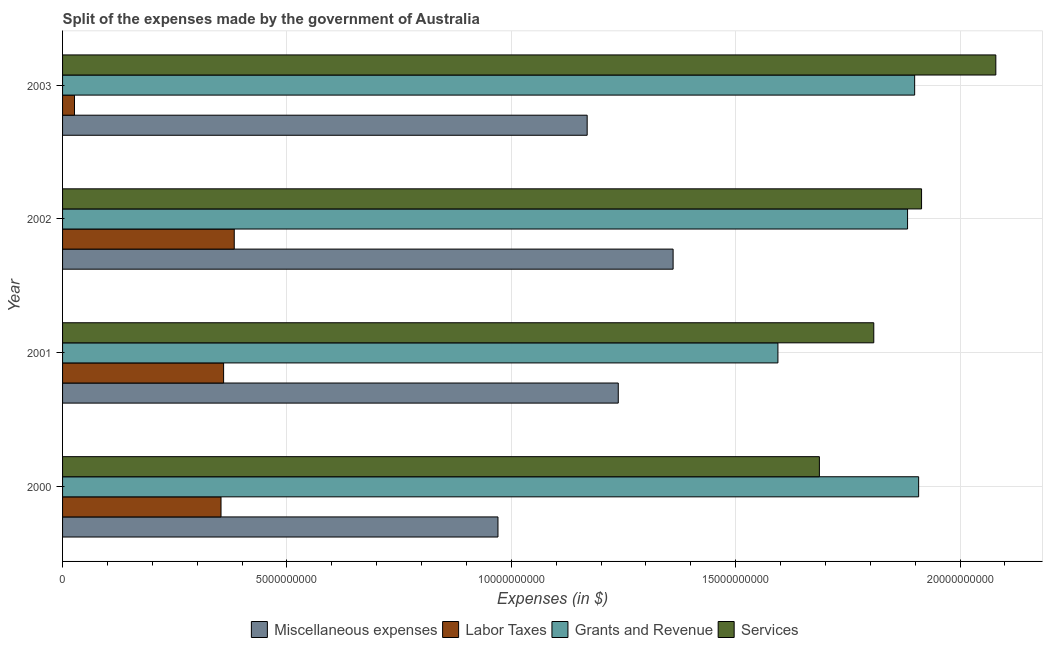How many different coloured bars are there?
Ensure brevity in your answer.  4. Are the number of bars on each tick of the Y-axis equal?
Your response must be concise. Yes. How many bars are there on the 1st tick from the bottom?
Provide a succinct answer. 4. What is the label of the 3rd group of bars from the top?
Provide a short and direct response. 2001. In how many cases, is the number of bars for a given year not equal to the number of legend labels?
Your answer should be compact. 0. What is the amount spent on services in 2000?
Offer a terse response. 1.69e+1. Across all years, what is the maximum amount spent on services?
Provide a short and direct response. 2.08e+1. Across all years, what is the minimum amount spent on services?
Your response must be concise. 1.69e+1. What is the total amount spent on miscellaneous expenses in the graph?
Make the answer very short. 4.74e+1. What is the difference between the amount spent on labor taxes in 2000 and that in 2001?
Offer a terse response. -5.80e+07. What is the difference between the amount spent on miscellaneous expenses in 2003 and the amount spent on labor taxes in 2002?
Ensure brevity in your answer.  7.86e+09. What is the average amount spent on grants and revenue per year?
Keep it short and to the point. 1.82e+1. In the year 2000, what is the difference between the amount spent on services and amount spent on labor taxes?
Offer a very short reply. 1.33e+1. In how many years, is the amount spent on labor taxes greater than 16000000000 $?
Your answer should be compact. 0. What is the ratio of the amount spent on services in 2001 to that in 2003?
Offer a very short reply. 0.87. What is the difference between the highest and the second highest amount spent on miscellaneous expenses?
Keep it short and to the point. 1.22e+09. What is the difference between the highest and the lowest amount spent on miscellaneous expenses?
Your answer should be very brief. 3.90e+09. In how many years, is the amount spent on miscellaneous expenses greater than the average amount spent on miscellaneous expenses taken over all years?
Provide a short and direct response. 2. What does the 1st bar from the top in 2001 represents?
Provide a succinct answer. Services. What does the 4th bar from the bottom in 2002 represents?
Offer a terse response. Services. Is it the case that in every year, the sum of the amount spent on miscellaneous expenses and amount spent on labor taxes is greater than the amount spent on grants and revenue?
Make the answer very short. No. How many bars are there?
Provide a short and direct response. 16. Are all the bars in the graph horizontal?
Your answer should be very brief. Yes. How many years are there in the graph?
Your response must be concise. 4. What is the difference between two consecutive major ticks on the X-axis?
Give a very brief answer. 5.00e+09. Are the values on the major ticks of X-axis written in scientific E-notation?
Provide a short and direct response. No. Where does the legend appear in the graph?
Offer a very short reply. Bottom center. How many legend labels are there?
Your answer should be compact. 4. How are the legend labels stacked?
Your response must be concise. Horizontal. What is the title of the graph?
Your answer should be very brief. Split of the expenses made by the government of Australia. What is the label or title of the X-axis?
Offer a terse response. Expenses (in $). What is the label or title of the Y-axis?
Keep it short and to the point. Year. What is the Expenses (in $) of Miscellaneous expenses in 2000?
Provide a short and direct response. 9.70e+09. What is the Expenses (in $) of Labor Taxes in 2000?
Provide a succinct answer. 3.53e+09. What is the Expenses (in $) of Grants and Revenue in 2000?
Make the answer very short. 1.91e+1. What is the Expenses (in $) in Services in 2000?
Your response must be concise. 1.69e+1. What is the Expenses (in $) in Miscellaneous expenses in 2001?
Provide a short and direct response. 1.24e+1. What is the Expenses (in $) in Labor Taxes in 2001?
Keep it short and to the point. 3.59e+09. What is the Expenses (in $) of Grants and Revenue in 2001?
Make the answer very short. 1.59e+1. What is the Expenses (in $) in Services in 2001?
Make the answer very short. 1.81e+1. What is the Expenses (in $) in Miscellaneous expenses in 2002?
Offer a very short reply. 1.36e+1. What is the Expenses (in $) in Labor Taxes in 2002?
Provide a short and direct response. 3.83e+09. What is the Expenses (in $) of Grants and Revenue in 2002?
Provide a succinct answer. 1.88e+1. What is the Expenses (in $) of Services in 2002?
Offer a terse response. 1.91e+1. What is the Expenses (in $) in Miscellaneous expenses in 2003?
Ensure brevity in your answer.  1.17e+1. What is the Expenses (in $) in Labor Taxes in 2003?
Ensure brevity in your answer.  2.66e+08. What is the Expenses (in $) in Grants and Revenue in 2003?
Provide a succinct answer. 1.90e+1. What is the Expenses (in $) of Services in 2003?
Offer a terse response. 2.08e+1. Across all years, what is the maximum Expenses (in $) in Miscellaneous expenses?
Offer a very short reply. 1.36e+1. Across all years, what is the maximum Expenses (in $) in Labor Taxes?
Make the answer very short. 3.83e+09. Across all years, what is the maximum Expenses (in $) of Grants and Revenue?
Offer a terse response. 1.91e+1. Across all years, what is the maximum Expenses (in $) of Services?
Offer a very short reply. 2.08e+1. Across all years, what is the minimum Expenses (in $) of Miscellaneous expenses?
Offer a terse response. 9.70e+09. Across all years, what is the minimum Expenses (in $) in Labor Taxes?
Your answer should be compact. 2.66e+08. Across all years, what is the minimum Expenses (in $) of Grants and Revenue?
Give a very brief answer. 1.59e+1. Across all years, what is the minimum Expenses (in $) of Services?
Your response must be concise. 1.69e+1. What is the total Expenses (in $) of Miscellaneous expenses in the graph?
Ensure brevity in your answer.  4.74e+1. What is the total Expenses (in $) in Labor Taxes in the graph?
Offer a terse response. 1.12e+1. What is the total Expenses (in $) in Grants and Revenue in the graph?
Provide a succinct answer. 7.28e+1. What is the total Expenses (in $) in Services in the graph?
Keep it short and to the point. 7.49e+1. What is the difference between the Expenses (in $) of Miscellaneous expenses in 2000 and that in 2001?
Give a very brief answer. -2.68e+09. What is the difference between the Expenses (in $) of Labor Taxes in 2000 and that in 2001?
Your answer should be compact. -5.80e+07. What is the difference between the Expenses (in $) in Grants and Revenue in 2000 and that in 2001?
Provide a succinct answer. 3.14e+09. What is the difference between the Expenses (in $) in Services in 2000 and that in 2001?
Provide a short and direct response. -1.21e+09. What is the difference between the Expenses (in $) of Miscellaneous expenses in 2000 and that in 2002?
Your response must be concise. -3.90e+09. What is the difference between the Expenses (in $) in Labor Taxes in 2000 and that in 2002?
Offer a very short reply. -2.95e+08. What is the difference between the Expenses (in $) of Grants and Revenue in 2000 and that in 2002?
Offer a very short reply. 2.47e+08. What is the difference between the Expenses (in $) of Services in 2000 and that in 2002?
Your response must be concise. -2.28e+09. What is the difference between the Expenses (in $) of Miscellaneous expenses in 2000 and that in 2003?
Keep it short and to the point. -1.99e+09. What is the difference between the Expenses (in $) in Labor Taxes in 2000 and that in 2003?
Give a very brief answer. 3.26e+09. What is the difference between the Expenses (in $) in Grants and Revenue in 2000 and that in 2003?
Your answer should be compact. 8.90e+07. What is the difference between the Expenses (in $) in Services in 2000 and that in 2003?
Give a very brief answer. -3.93e+09. What is the difference between the Expenses (in $) in Miscellaneous expenses in 2001 and that in 2002?
Your response must be concise. -1.22e+09. What is the difference between the Expenses (in $) in Labor Taxes in 2001 and that in 2002?
Offer a terse response. -2.37e+08. What is the difference between the Expenses (in $) in Grants and Revenue in 2001 and that in 2002?
Your answer should be very brief. -2.89e+09. What is the difference between the Expenses (in $) of Services in 2001 and that in 2002?
Your answer should be very brief. -1.06e+09. What is the difference between the Expenses (in $) of Miscellaneous expenses in 2001 and that in 2003?
Your answer should be compact. 6.93e+08. What is the difference between the Expenses (in $) of Labor Taxes in 2001 and that in 2003?
Offer a terse response. 3.32e+09. What is the difference between the Expenses (in $) of Grants and Revenue in 2001 and that in 2003?
Your answer should be compact. -3.05e+09. What is the difference between the Expenses (in $) in Services in 2001 and that in 2003?
Your answer should be very brief. -2.72e+09. What is the difference between the Expenses (in $) in Miscellaneous expenses in 2002 and that in 2003?
Your response must be concise. 1.92e+09. What is the difference between the Expenses (in $) in Labor Taxes in 2002 and that in 2003?
Provide a short and direct response. 3.56e+09. What is the difference between the Expenses (in $) in Grants and Revenue in 2002 and that in 2003?
Give a very brief answer. -1.58e+08. What is the difference between the Expenses (in $) in Services in 2002 and that in 2003?
Provide a short and direct response. -1.66e+09. What is the difference between the Expenses (in $) in Miscellaneous expenses in 2000 and the Expenses (in $) in Labor Taxes in 2001?
Keep it short and to the point. 6.11e+09. What is the difference between the Expenses (in $) of Miscellaneous expenses in 2000 and the Expenses (in $) of Grants and Revenue in 2001?
Ensure brevity in your answer.  -6.24e+09. What is the difference between the Expenses (in $) of Miscellaneous expenses in 2000 and the Expenses (in $) of Services in 2001?
Make the answer very short. -8.38e+09. What is the difference between the Expenses (in $) in Labor Taxes in 2000 and the Expenses (in $) in Grants and Revenue in 2001?
Ensure brevity in your answer.  -1.24e+1. What is the difference between the Expenses (in $) in Labor Taxes in 2000 and the Expenses (in $) in Services in 2001?
Provide a succinct answer. -1.45e+1. What is the difference between the Expenses (in $) in Miscellaneous expenses in 2000 and the Expenses (in $) in Labor Taxes in 2002?
Provide a short and direct response. 5.88e+09. What is the difference between the Expenses (in $) in Miscellaneous expenses in 2000 and the Expenses (in $) in Grants and Revenue in 2002?
Make the answer very short. -9.13e+09. What is the difference between the Expenses (in $) in Miscellaneous expenses in 2000 and the Expenses (in $) in Services in 2002?
Make the answer very short. -9.44e+09. What is the difference between the Expenses (in $) in Labor Taxes in 2000 and the Expenses (in $) in Grants and Revenue in 2002?
Provide a succinct answer. -1.53e+1. What is the difference between the Expenses (in $) in Labor Taxes in 2000 and the Expenses (in $) in Services in 2002?
Your answer should be compact. -1.56e+1. What is the difference between the Expenses (in $) in Grants and Revenue in 2000 and the Expenses (in $) in Services in 2002?
Provide a succinct answer. -6.50e+07. What is the difference between the Expenses (in $) of Miscellaneous expenses in 2000 and the Expenses (in $) of Labor Taxes in 2003?
Your answer should be compact. 9.44e+09. What is the difference between the Expenses (in $) of Miscellaneous expenses in 2000 and the Expenses (in $) of Grants and Revenue in 2003?
Ensure brevity in your answer.  -9.29e+09. What is the difference between the Expenses (in $) of Miscellaneous expenses in 2000 and the Expenses (in $) of Services in 2003?
Offer a very short reply. -1.11e+1. What is the difference between the Expenses (in $) of Labor Taxes in 2000 and the Expenses (in $) of Grants and Revenue in 2003?
Ensure brevity in your answer.  -1.55e+1. What is the difference between the Expenses (in $) of Labor Taxes in 2000 and the Expenses (in $) of Services in 2003?
Make the answer very short. -1.73e+1. What is the difference between the Expenses (in $) in Grants and Revenue in 2000 and the Expenses (in $) in Services in 2003?
Provide a short and direct response. -1.72e+09. What is the difference between the Expenses (in $) of Miscellaneous expenses in 2001 and the Expenses (in $) of Labor Taxes in 2002?
Offer a terse response. 8.56e+09. What is the difference between the Expenses (in $) in Miscellaneous expenses in 2001 and the Expenses (in $) in Grants and Revenue in 2002?
Provide a succinct answer. -6.45e+09. What is the difference between the Expenses (in $) in Miscellaneous expenses in 2001 and the Expenses (in $) in Services in 2002?
Give a very brief answer. -6.76e+09. What is the difference between the Expenses (in $) in Labor Taxes in 2001 and the Expenses (in $) in Grants and Revenue in 2002?
Offer a terse response. -1.52e+1. What is the difference between the Expenses (in $) of Labor Taxes in 2001 and the Expenses (in $) of Services in 2002?
Offer a terse response. -1.56e+1. What is the difference between the Expenses (in $) in Grants and Revenue in 2001 and the Expenses (in $) in Services in 2002?
Your answer should be very brief. -3.20e+09. What is the difference between the Expenses (in $) of Miscellaneous expenses in 2001 and the Expenses (in $) of Labor Taxes in 2003?
Provide a succinct answer. 1.21e+1. What is the difference between the Expenses (in $) in Miscellaneous expenses in 2001 and the Expenses (in $) in Grants and Revenue in 2003?
Provide a succinct answer. -6.60e+09. What is the difference between the Expenses (in $) in Miscellaneous expenses in 2001 and the Expenses (in $) in Services in 2003?
Offer a very short reply. -8.41e+09. What is the difference between the Expenses (in $) of Labor Taxes in 2001 and the Expenses (in $) of Grants and Revenue in 2003?
Ensure brevity in your answer.  -1.54e+1. What is the difference between the Expenses (in $) of Labor Taxes in 2001 and the Expenses (in $) of Services in 2003?
Your answer should be compact. -1.72e+1. What is the difference between the Expenses (in $) of Grants and Revenue in 2001 and the Expenses (in $) of Services in 2003?
Offer a very short reply. -4.86e+09. What is the difference between the Expenses (in $) of Miscellaneous expenses in 2002 and the Expenses (in $) of Labor Taxes in 2003?
Your answer should be compact. 1.33e+1. What is the difference between the Expenses (in $) in Miscellaneous expenses in 2002 and the Expenses (in $) in Grants and Revenue in 2003?
Give a very brief answer. -5.38e+09. What is the difference between the Expenses (in $) in Miscellaneous expenses in 2002 and the Expenses (in $) in Services in 2003?
Your answer should be very brief. -7.19e+09. What is the difference between the Expenses (in $) in Labor Taxes in 2002 and the Expenses (in $) in Grants and Revenue in 2003?
Offer a very short reply. -1.52e+1. What is the difference between the Expenses (in $) in Labor Taxes in 2002 and the Expenses (in $) in Services in 2003?
Your response must be concise. -1.70e+1. What is the difference between the Expenses (in $) in Grants and Revenue in 2002 and the Expenses (in $) in Services in 2003?
Make the answer very short. -1.97e+09. What is the average Expenses (in $) of Miscellaneous expenses per year?
Your answer should be very brief. 1.18e+1. What is the average Expenses (in $) of Labor Taxes per year?
Offer a terse response. 2.80e+09. What is the average Expenses (in $) in Grants and Revenue per year?
Offer a very short reply. 1.82e+1. What is the average Expenses (in $) of Services per year?
Your answer should be very brief. 1.87e+1. In the year 2000, what is the difference between the Expenses (in $) in Miscellaneous expenses and Expenses (in $) in Labor Taxes?
Give a very brief answer. 6.17e+09. In the year 2000, what is the difference between the Expenses (in $) in Miscellaneous expenses and Expenses (in $) in Grants and Revenue?
Your answer should be compact. -9.38e+09. In the year 2000, what is the difference between the Expenses (in $) of Miscellaneous expenses and Expenses (in $) of Services?
Keep it short and to the point. -7.16e+09. In the year 2000, what is the difference between the Expenses (in $) in Labor Taxes and Expenses (in $) in Grants and Revenue?
Your answer should be very brief. -1.55e+1. In the year 2000, what is the difference between the Expenses (in $) in Labor Taxes and Expenses (in $) in Services?
Your response must be concise. -1.33e+1. In the year 2000, what is the difference between the Expenses (in $) in Grants and Revenue and Expenses (in $) in Services?
Your response must be concise. 2.21e+09. In the year 2001, what is the difference between the Expenses (in $) in Miscellaneous expenses and Expenses (in $) in Labor Taxes?
Your answer should be very brief. 8.80e+09. In the year 2001, what is the difference between the Expenses (in $) in Miscellaneous expenses and Expenses (in $) in Grants and Revenue?
Make the answer very short. -3.56e+09. In the year 2001, what is the difference between the Expenses (in $) of Miscellaneous expenses and Expenses (in $) of Services?
Give a very brief answer. -5.69e+09. In the year 2001, what is the difference between the Expenses (in $) of Labor Taxes and Expenses (in $) of Grants and Revenue?
Your answer should be very brief. -1.24e+1. In the year 2001, what is the difference between the Expenses (in $) in Labor Taxes and Expenses (in $) in Services?
Provide a short and direct response. -1.45e+1. In the year 2001, what is the difference between the Expenses (in $) in Grants and Revenue and Expenses (in $) in Services?
Ensure brevity in your answer.  -2.14e+09. In the year 2002, what is the difference between the Expenses (in $) of Miscellaneous expenses and Expenses (in $) of Labor Taxes?
Keep it short and to the point. 9.78e+09. In the year 2002, what is the difference between the Expenses (in $) in Miscellaneous expenses and Expenses (in $) in Grants and Revenue?
Make the answer very short. -5.22e+09. In the year 2002, what is the difference between the Expenses (in $) of Miscellaneous expenses and Expenses (in $) of Services?
Offer a very short reply. -5.54e+09. In the year 2002, what is the difference between the Expenses (in $) in Labor Taxes and Expenses (in $) in Grants and Revenue?
Provide a short and direct response. -1.50e+1. In the year 2002, what is the difference between the Expenses (in $) in Labor Taxes and Expenses (in $) in Services?
Give a very brief answer. -1.53e+1. In the year 2002, what is the difference between the Expenses (in $) of Grants and Revenue and Expenses (in $) of Services?
Your response must be concise. -3.12e+08. In the year 2003, what is the difference between the Expenses (in $) of Miscellaneous expenses and Expenses (in $) of Labor Taxes?
Keep it short and to the point. 1.14e+1. In the year 2003, what is the difference between the Expenses (in $) of Miscellaneous expenses and Expenses (in $) of Grants and Revenue?
Provide a short and direct response. -7.30e+09. In the year 2003, what is the difference between the Expenses (in $) in Miscellaneous expenses and Expenses (in $) in Services?
Offer a terse response. -9.11e+09. In the year 2003, what is the difference between the Expenses (in $) in Labor Taxes and Expenses (in $) in Grants and Revenue?
Your response must be concise. -1.87e+1. In the year 2003, what is the difference between the Expenses (in $) of Labor Taxes and Expenses (in $) of Services?
Keep it short and to the point. -2.05e+1. In the year 2003, what is the difference between the Expenses (in $) of Grants and Revenue and Expenses (in $) of Services?
Your response must be concise. -1.81e+09. What is the ratio of the Expenses (in $) in Miscellaneous expenses in 2000 to that in 2001?
Give a very brief answer. 0.78. What is the ratio of the Expenses (in $) of Labor Taxes in 2000 to that in 2001?
Make the answer very short. 0.98. What is the ratio of the Expenses (in $) of Grants and Revenue in 2000 to that in 2001?
Give a very brief answer. 1.2. What is the ratio of the Expenses (in $) in Services in 2000 to that in 2001?
Offer a very short reply. 0.93. What is the ratio of the Expenses (in $) of Miscellaneous expenses in 2000 to that in 2002?
Provide a short and direct response. 0.71. What is the ratio of the Expenses (in $) of Labor Taxes in 2000 to that in 2002?
Ensure brevity in your answer.  0.92. What is the ratio of the Expenses (in $) of Grants and Revenue in 2000 to that in 2002?
Provide a short and direct response. 1.01. What is the ratio of the Expenses (in $) of Services in 2000 to that in 2002?
Offer a very short reply. 0.88. What is the ratio of the Expenses (in $) of Miscellaneous expenses in 2000 to that in 2003?
Offer a very short reply. 0.83. What is the ratio of the Expenses (in $) in Labor Taxes in 2000 to that in 2003?
Your answer should be compact. 13.27. What is the ratio of the Expenses (in $) of Grants and Revenue in 2000 to that in 2003?
Keep it short and to the point. 1. What is the ratio of the Expenses (in $) in Services in 2000 to that in 2003?
Make the answer very short. 0.81. What is the ratio of the Expenses (in $) in Miscellaneous expenses in 2001 to that in 2002?
Your answer should be compact. 0.91. What is the ratio of the Expenses (in $) of Labor Taxes in 2001 to that in 2002?
Keep it short and to the point. 0.94. What is the ratio of the Expenses (in $) of Grants and Revenue in 2001 to that in 2002?
Provide a succinct answer. 0.85. What is the ratio of the Expenses (in $) of Miscellaneous expenses in 2001 to that in 2003?
Offer a very short reply. 1.06. What is the ratio of the Expenses (in $) in Labor Taxes in 2001 to that in 2003?
Your answer should be very brief. 13.49. What is the ratio of the Expenses (in $) in Grants and Revenue in 2001 to that in 2003?
Make the answer very short. 0.84. What is the ratio of the Expenses (in $) of Services in 2001 to that in 2003?
Offer a terse response. 0.87. What is the ratio of the Expenses (in $) in Miscellaneous expenses in 2002 to that in 2003?
Keep it short and to the point. 1.16. What is the ratio of the Expenses (in $) in Labor Taxes in 2002 to that in 2003?
Your response must be concise. 14.38. What is the ratio of the Expenses (in $) of Services in 2002 to that in 2003?
Ensure brevity in your answer.  0.92. What is the difference between the highest and the second highest Expenses (in $) in Miscellaneous expenses?
Your response must be concise. 1.22e+09. What is the difference between the highest and the second highest Expenses (in $) of Labor Taxes?
Provide a short and direct response. 2.37e+08. What is the difference between the highest and the second highest Expenses (in $) in Grants and Revenue?
Give a very brief answer. 8.90e+07. What is the difference between the highest and the second highest Expenses (in $) of Services?
Provide a succinct answer. 1.66e+09. What is the difference between the highest and the lowest Expenses (in $) in Miscellaneous expenses?
Give a very brief answer. 3.90e+09. What is the difference between the highest and the lowest Expenses (in $) in Labor Taxes?
Provide a succinct answer. 3.56e+09. What is the difference between the highest and the lowest Expenses (in $) of Grants and Revenue?
Keep it short and to the point. 3.14e+09. What is the difference between the highest and the lowest Expenses (in $) in Services?
Make the answer very short. 3.93e+09. 